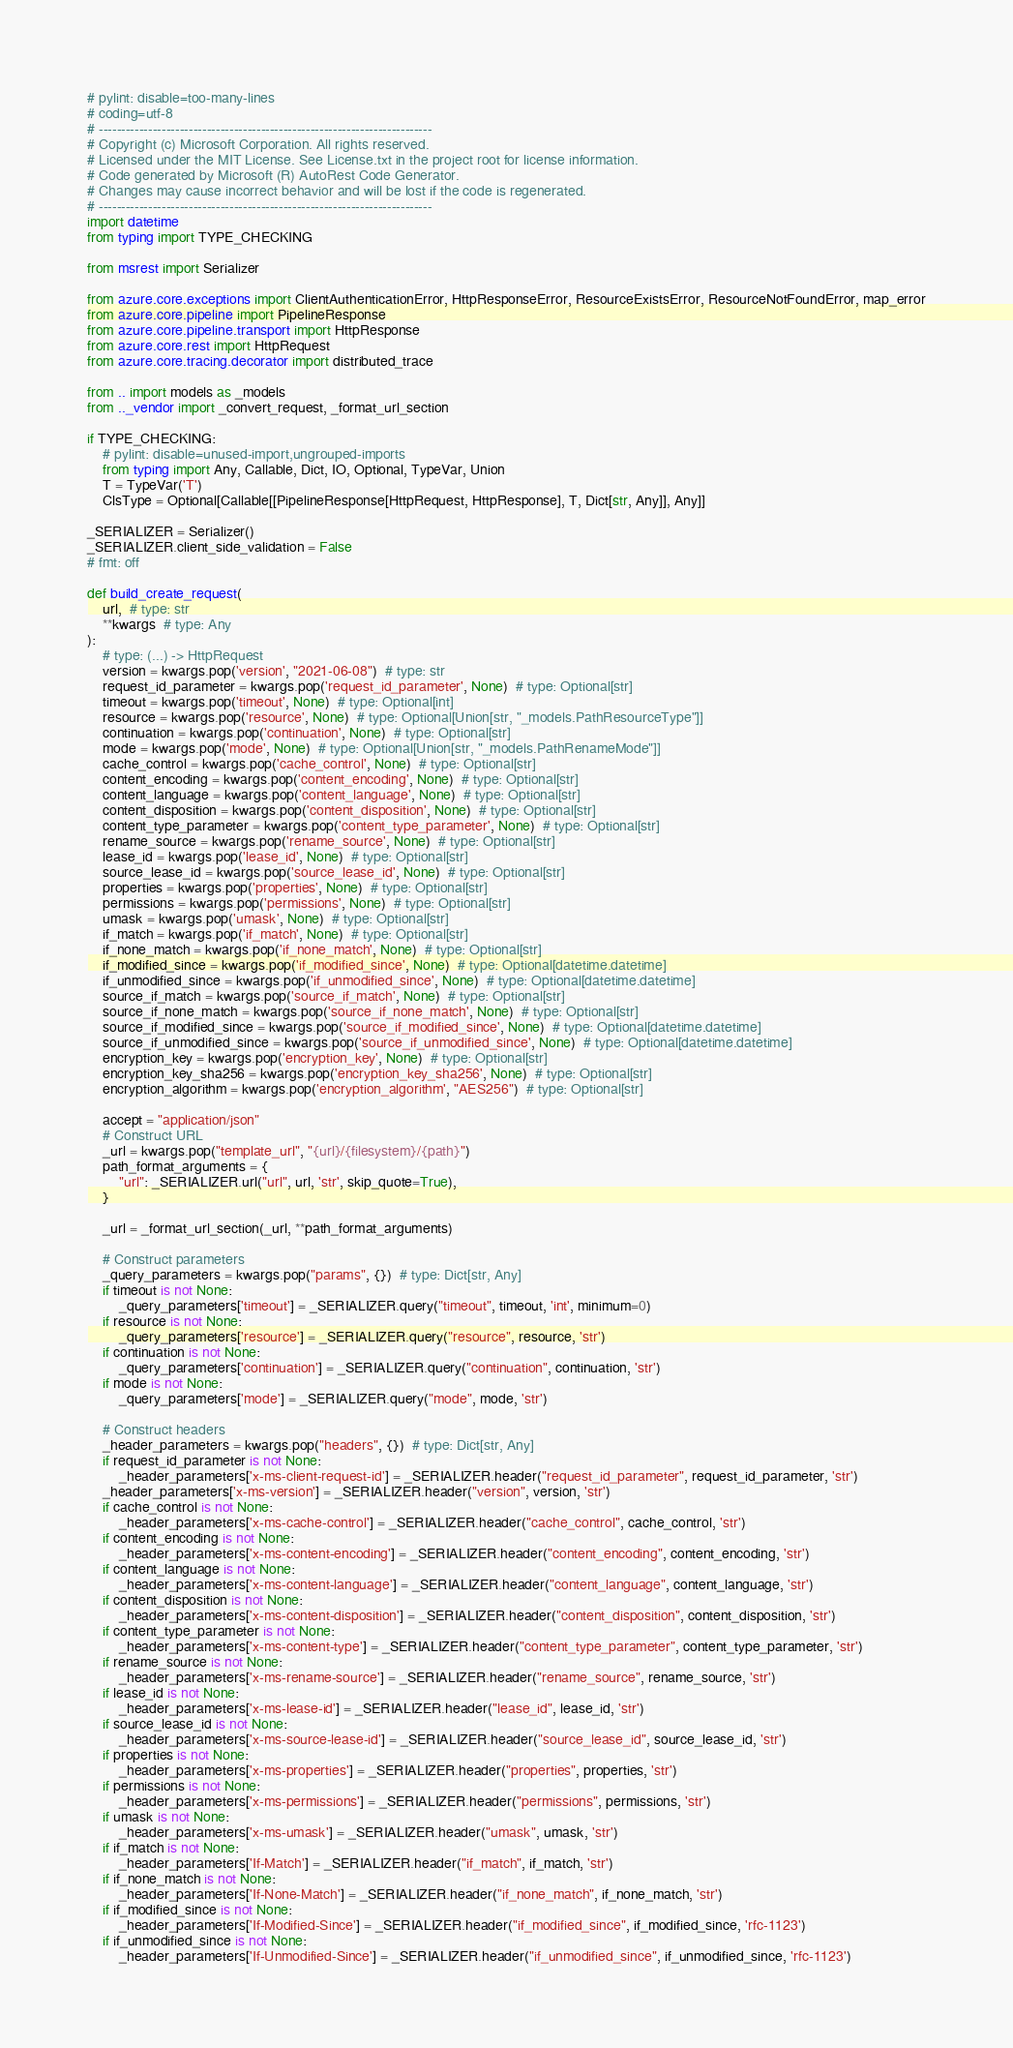Convert code to text. <code><loc_0><loc_0><loc_500><loc_500><_Python_># pylint: disable=too-many-lines
# coding=utf-8
# --------------------------------------------------------------------------
# Copyright (c) Microsoft Corporation. All rights reserved.
# Licensed under the MIT License. See License.txt in the project root for license information.
# Code generated by Microsoft (R) AutoRest Code Generator.
# Changes may cause incorrect behavior and will be lost if the code is regenerated.
# --------------------------------------------------------------------------
import datetime
from typing import TYPE_CHECKING

from msrest import Serializer

from azure.core.exceptions import ClientAuthenticationError, HttpResponseError, ResourceExistsError, ResourceNotFoundError, map_error
from azure.core.pipeline import PipelineResponse
from azure.core.pipeline.transport import HttpResponse
from azure.core.rest import HttpRequest
from azure.core.tracing.decorator import distributed_trace

from .. import models as _models
from .._vendor import _convert_request, _format_url_section

if TYPE_CHECKING:
    # pylint: disable=unused-import,ungrouped-imports
    from typing import Any, Callable, Dict, IO, Optional, TypeVar, Union
    T = TypeVar('T')
    ClsType = Optional[Callable[[PipelineResponse[HttpRequest, HttpResponse], T, Dict[str, Any]], Any]]

_SERIALIZER = Serializer()
_SERIALIZER.client_side_validation = False
# fmt: off

def build_create_request(
    url,  # type: str
    **kwargs  # type: Any
):
    # type: (...) -> HttpRequest
    version = kwargs.pop('version', "2021-06-08")  # type: str
    request_id_parameter = kwargs.pop('request_id_parameter', None)  # type: Optional[str]
    timeout = kwargs.pop('timeout', None)  # type: Optional[int]
    resource = kwargs.pop('resource', None)  # type: Optional[Union[str, "_models.PathResourceType"]]
    continuation = kwargs.pop('continuation', None)  # type: Optional[str]
    mode = kwargs.pop('mode', None)  # type: Optional[Union[str, "_models.PathRenameMode"]]
    cache_control = kwargs.pop('cache_control', None)  # type: Optional[str]
    content_encoding = kwargs.pop('content_encoding', None)  # type: Optional[str]
    content_language = kwargs.pop('content_language', None)  # type: Optional[str]
    content_disposition = kwargs.pop('content_disposition', None)  # type: Optional[str]
    content_type_parameter = kwargs.pop('content_type_parameter', None)  # type: Optional[str]
    rename_source = kwargs.pop('rename_source', None)  # type: Optional[str]
    lease_id = kwargs.pop('lease_id', None)  # type: Optional[str]
    source_lease_id = kwargs.pop('source_lease_id', None)  # type: Optional[str]
    properties = kwargs.pop('properties', None)  # type: Optional[str]
    permissions = kwargs.pop('permissions', None)  # type: Optional[str]
    umask = kwargs.pop('umask', None)  # type: Optional[str]
    if_match = kwargs.pop('if_match', None)  # type: Optional[str]
    if_none_match = kwargs.pop('if_none_match', None)  # type: Optional[str]
    if_modified_since = kwargs.pop('if_modified_since', None)  # type: Optional[datetime.datetime]
    if_unmodified_since = kwargs.pop('if_unmodified_since', None)  # type: Optional[datetime.datetime]
    source_if_match = kwargs.pop('source_if_match', None)  # type: Optional[str]
    source_if_none_match = kwargs.pop('source_if_none_match', None)  # type: Optional[str]
    source_if_modified_since = kwargs.pop('source_if_modified_since', None)  # type: Optional[datetime.datetime]
    source_if_unmodified_since = kwargs.pop('source_if_unmodified_since', None)  # type: Optional[datetime.datetime]
    encryption_key = kwargs.pop('encryption_key', None)  # type: Optional[str]
    encryption_key_sha256 = kwargs.pop('encryption_key_sha256', None)  # type: Optional[str]
    encryption_algorithm = kwargs.pop('encryption_algorithm', "AES256")  # type: Optional[str]

    accept = "application/json"
    # Construct URL
    _url = kwargs.pop("template_url", "{url}/{filesystem}/{path}")
    path_format_arguments = {
        "url": _SERIALIZER.url("url", url, 'str', skip_quote=True),
    }

    _url = _format_url_section(_url, **path_format_arguments)

    # Construct parameters
    _query_parameters = kwargs.pop("params", {})  # type: Dict[str, Any]
    if timeout is not None:
        _query_parameters['timeout'] = _SERIALIZER.query("timeout", timeout, 'int', minimum=0)
    if resource is not None:
        _query_parameters['resource'] = _SERIALIZER.query("resource", resource, 'str')
    if continuation is not None:
        _query_parameters['continuation'] = _SERIALIZER.query("continuation", continuation, 'str')
    if mode is not None:
        _query_parameters['mode'] = _SERIALIZER.query("mode", mode, 'str')

    # Construct headers
    _header_parameters = kwargs.pop("headers", {})  # type: Dict[str, Any]
    if request_id_parameter is not None:
        _header_parameters['x-ms-client-request-id'] = _SERIALIZER.header("request_id_parameter", request_id_parameter, 'str')
    _header_parameters['x-ms-version'] = _SERIALIZER.header("version", version, 'str')
    if cache_control is not None:
        _header_parameters['x-ms-cache-control'] = _SERIALIZER.header("cache_control", cache_control, 'str')
    if content_encoding is not None:
        _header_parameters['x-ms-content-encoding'] = _SERIALIZER.header("content_encoding", content_encoding, 'str')
    if content_language is not None:
        _header_parameters['x-ms-content-language'] = _SERIALIZER.header("content_language", content_language, 'str')
    if content_disposition is not None:
        _header_parameters['x-ms-content-disposition'] = _SERIALIZER.header("content_disposition", content_disposition, 'str')
    if content_type_parameter is not None:
        _header_parameters['x-ms-content-type'] = _SERIALIZER.header("content_type_parameter", content_type_parameter, 'str')
    if rename_source is not None:
        _header_parameters['x-ms-rename-source'] = _SERIALIZER.header("rename_source", rename_source, 'str')
    if lease_id is not None:
        _header_parameters['x-ms-lease-id'] = _SERIALIZER.header("lease_id", lease_id, 'str')
    if source_lease_id is not None:
        _header_parameters['x-ms-source-lease-id'] = _SERIALIZER.header("source_lease_id", source_lease_id, 'str')
    if properties is not None:
        _header_parameters['x-ms-properties'] = _SERIALIZER.header("properties", properties, 'str')
    if permissions is not None:
        _header_parameters['x-ms-permissions'] = _SERIALIZER.header("permissions", permissions, 'str')
    if umask is not None:
        _header_parameters['x-ms-umask'] = _SERIALIZER.header("umask", umask, 'str')
    if if_match is not None:
        _header_parameters['If-Match'] = _SERIALIZER.header("if_match", if_match, 'str')
    if if_none_match is not None:
        _header_parameters['If-None-Match'] = _SERIALIZER.header("if_none_match", if_none_match, 'str')
    if if_modified_since is not None:
        _header_parameters['If-Modified-Since'] = _SERIALIZER.header("if_modified_since", if_modified_since, 'rfc-1123')
    if if_unmodified_since is not None:
        _header_parameters['If-Unmodified-Since'] = _SERIALIZER.header("if_unmodified_since", if_unmodified_since, 'rfc-1123')</code> 